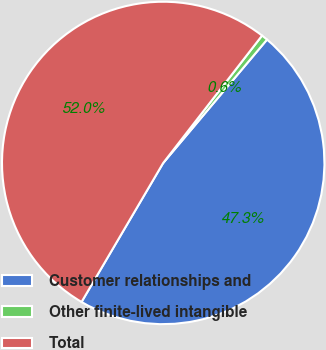Convert chart to OTSL. <chart><loc_0><loc_0><loc_500><loc_500><pie_chart><fcel>Customer relationships and<fcel>Other finite-lived intangible<fcel>Total<nl><fcel>47.32%<fcel>0.63%<fcel>52.05%<nl></chart> 